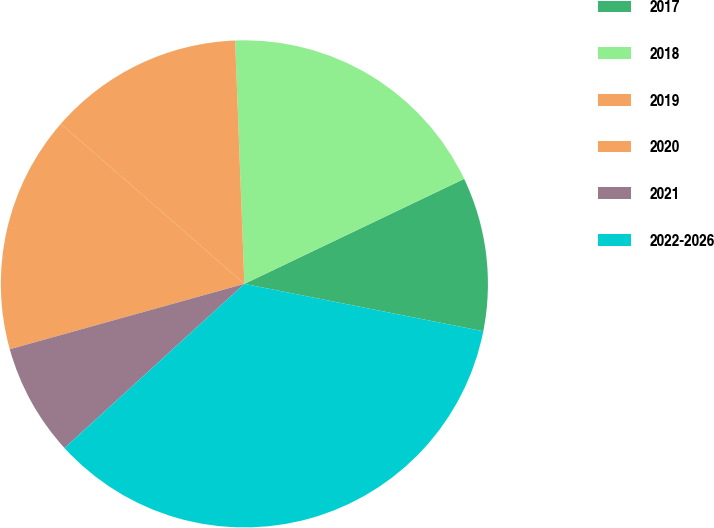Convert chart. <chart><loc_0><loc_0><loc_500><loc_500><pie_chart><fcel>2017<fcel>2018<fcel>2019<fcel>2020<fcel>2021<fcel>2022-2026<nl><fcel>10.21%<fcel>18.51%<fcel>12.98%<fcel>15.74%<fcel>7.45%<fcel>35.11%<nl></chart> 